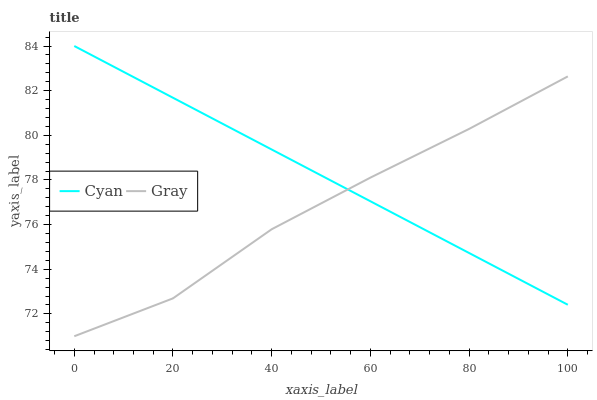Does Gray have the minimum area under the curve?
Answer yes or no. Yes. Does Cyan have the maximum area under the curve?
Answer yes or no. Yes. Does Gray have the maximum area under the curve?
Answer yes or no. No. Is Cyan the smoothest?
Answer yes or no. Yes. Is Gray the roughest?
Answer yes or no. Yes. Is Gray the smoothest?
Answer yes or no. No. Does Gray have the lowest value?
Answer yes or no. Yes. Does Cyan have the highest value?
Answer yes or no. Yes. Does Gray have the highest value?
Answer yes or no. No. Does Cyan intersect Gray?
Answer yes or no. Yes. Is Cyan less than Gray?
Answer yes or no. No. Is Cyan greater than Gray?
Answer yes or no. No. 